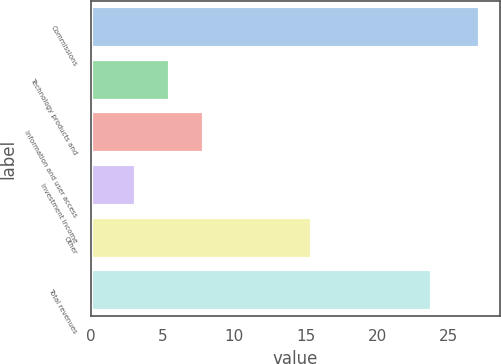<chart> <loc_0><loc_0><loc_500><loc_500><bar_chart><fcel>Commissions<fcel>Technology products and<fcel>Information and user access<fcel>Investment income<fcel>Other<fcel>Total revenues<nl><fcel>27.2<fcel>5.51<fcel>7.92<fcel>3.1<fcel>15.4<fcel>23.8<nl></chart> 